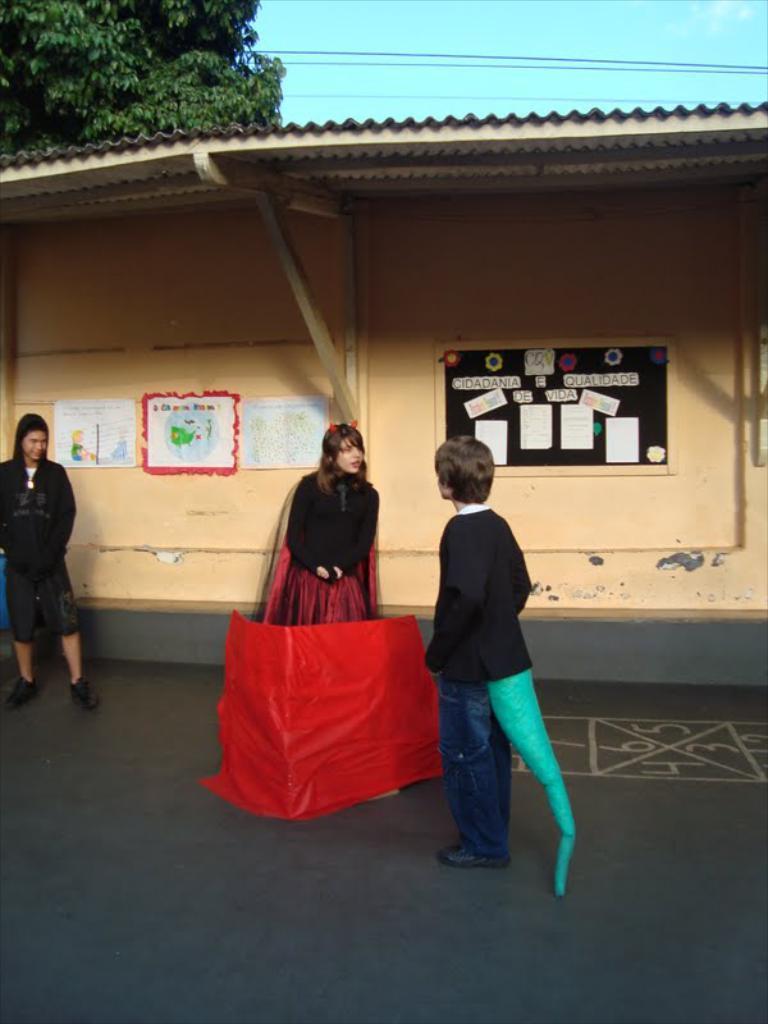Please provide a concise description of this image. In this picture we can see three people on the road, here we can see a red color sheet and in the background we can see a shelter, posters, trees, wires and the sky. 